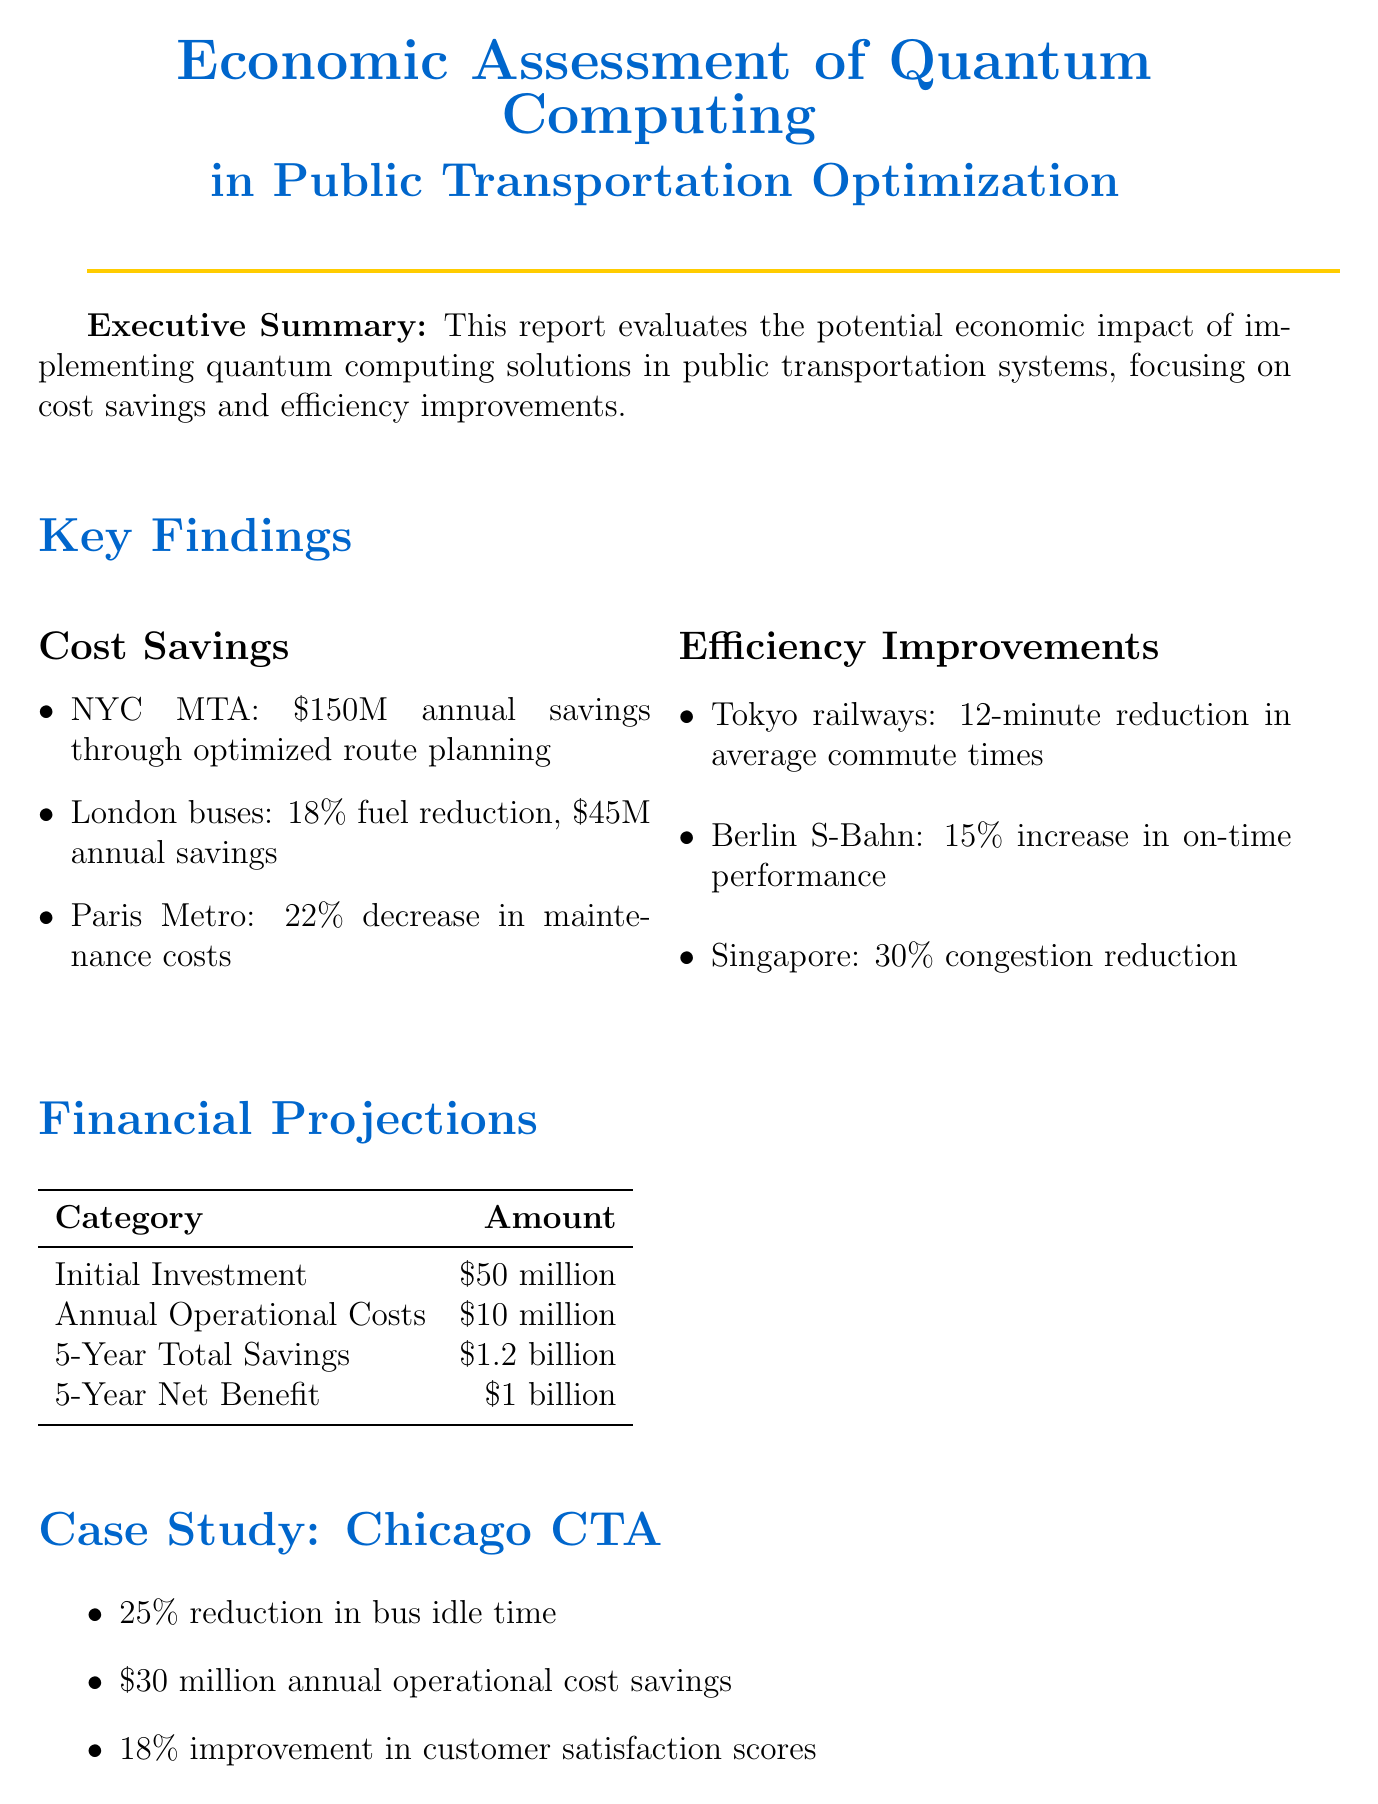What is the projected annual savings for the NYC MTA? The projected annual savings for the NYC MTA from optimized route planning is $150 million.
Answer: $150 million What percentage reduction in fuel consumption is noted for London's bus network? The report states that there is an 18% reduction in fuel consumption for London's bus network.
Answer: 18% What is the initial investment cost for quantum hardware and software integration? The document specifies the initial investment cost for quantum hardware and software integration as $50 million.
Answer: $50 million How much are the total savings projected over 5 years? The total savings projected over 5 years is $1.2 billion.
Answer: $1.2 billion What is the annual operational cost mentioned in the report? The annual operational cost for maintenance and updates is stated as $10 million.
Answer: $10 million What city is mentioned in the case study? The city mentioned in the case study is Chicago.
Answer: Chicago What was the improvement in customer satisfaction scores in the Chicago CTA project? The improvement in customer satisfaction scores from the CTA Quantum Optimization Initiative is noted as 18%.
Answer: 18% What type of partnerships does the report recommend establishing? The report recommends establishing partnerships with tech companies.
Answer: tech companies What is the conclusion of the report regarding quantum computing's promise? The conclusion states that quantum computing shows significant promise in optimizing public transportation systems.
Answer: significant promise 